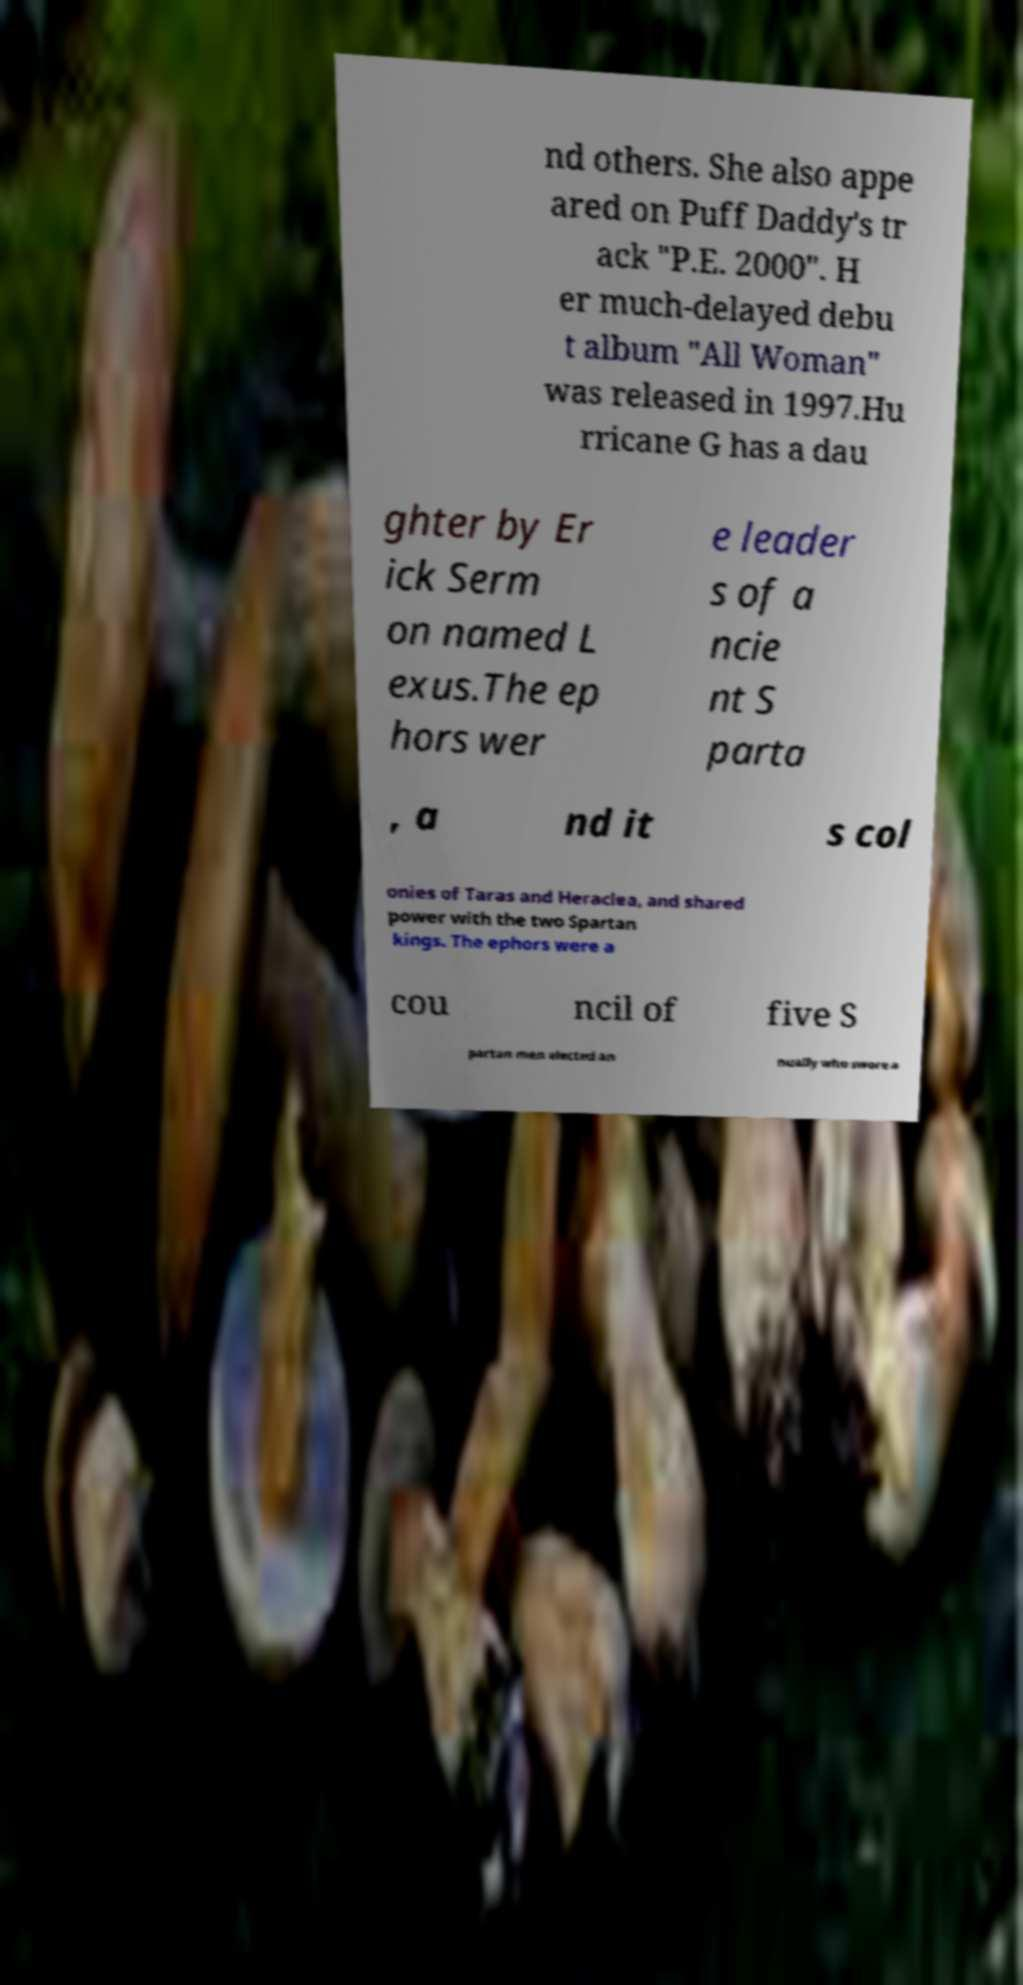Could you assist in decoding the text presented in this image and type it out clearly? nd others. She also appe ared on Puff Daddy's tr ack "P.E. 2000". H er much-delayed debu t album "All Woman" was released in 1997.Hu rricane G has a dau ghter by Er ick Serm on named L exus.The ep hors wer e leader s of a ncie nt S parta , a nd it s col onies of Taras and Heraclea, and shared power with the two Spartan kings. The ephors were a cou ncil of five S partan men elected an nually who swore a 